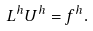Convert formula to latex. <formula><loc_0><loc_0><loc_500><loc_500>L ^ { h } U ^ { h } = f ^ { h } .</formula> 